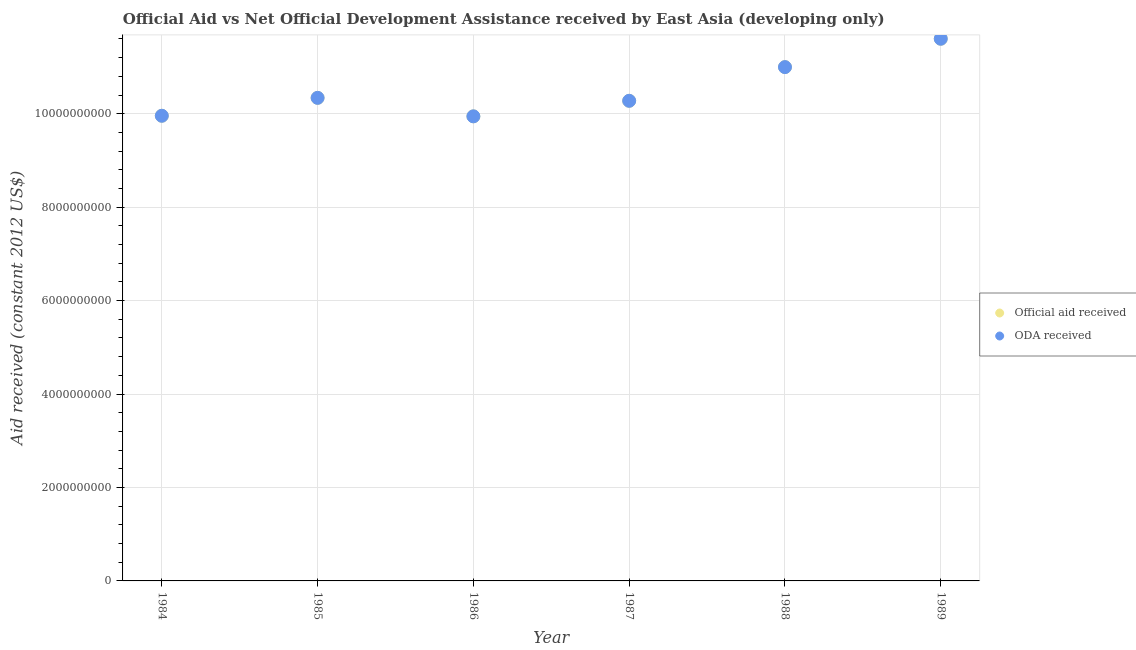How many different coloured dotlines are there?
Keep it short and to the point. 2. What is the oda received in 1988?
Your answer should be very brief. 1.10e+1. Across all years, what is the maximum oda received?
Provide a short and direct response. 1.16e+1. Across all years, what is the minimum oda received?
Your answer should be very brief. 9.94e+09. In which year was the oda received maximum?
Your answer should be compact. 1989. What is the total oda received in the graph?
Provide a succinct answer. 6.31e+1. What is the difference between the official aid received in 1984 and that in 1987?
Give a very brief answer. -3.20e+08. What is the difference between the oda received in 1985 and the official aid received in 1987?
Ensure brevity in your answer.  6.34e+07. What is the average oda received per year?
Provide a short and direct response. 1.05e+1. In how many years, is the oda received greater than 4400000000 US$?
Give a very brief answer. 6. What is the ratio of the official aid received in 1988 to that in 1989?
Make the answer very short. 0.95. Is the difference between the oda received in 1985 and 1988 greater than the difference between the official aid received in 1985 and 1988?
Your answer should be very brief. No. What is the difference between the highest and the second highest oda received?
Give a very brief answer. 6.07e+08. What is the difference between the highest and the lowest oda received?
Keep it short and to the point. 1.66e+09. In how many years, is the official aid received greater than the average official aid received taken over all years?
Your response must be concise. 2. Is the sum of the oda received in 1986 and 1987 greater than the maximum official aid received across all years?
Offer a very short reply. Yes. Is the official aid received strictly greater than the oda received over the years?
Your answer should be compact. No. Is the oda received strictly less than the official aid received over the years?
Make the answer very short. No. Does the graph contain any zero values?
Provide a succinct answer. No. Does the graph contain grids?
Ensure brevity in your answer.  Yes. What is the title of the graph?
Provide a short and direct response. Official Aid vs Net Official Development Assistance received by East Asia (developing only) . What is the label or title of the Y-axis?
Ensure brevity in your answer.  Aid received (constant 2012 US$). What is the Aid received (constant 2012 US$) in Official aid received in 1984?
Keep it short and to the point. 9.96e+09. What is the Aid received (constant 2012 US$) of ODA received in 1984?
Keep it short and to the point. 9.96e+09. What is the Aid received (constant 2012 US$) in Official aid received in 1985?
Make the answer very short. 1.03e+1. What is the Aid received (constant 2012 US$) of ODA received in 1985?
Offer a terse response. 1.03e+1. What is the Aid received (constant 2012 US$) of Official aid received in 1986?
Your response must be concise. 9.94e+09. What is the Aid received (constant 2012 US$) of ODA received in 1986?
Your response must be concise. 9.94e+09. What is the Aid received (constant 2012 US$) of Official aid received in 1987?
Provide a succinct answer. 1.03e+1. What is the Aid received (constant 2012 US$) in ODA received in 1987?
Give a very brief answer. 1.03e+1. What is the Aid received (constant 2012 US$) in Official aid received in 1988?
Give a very brief answer. 1.10e+1. What is the Aid received (constant 2012 US$) of ODA received in 1988?
Your answer should be compact. 1.10e+1. What is the Aid received (constant 2012 US$) of Official aid received in 1989?
Give a very brief answer. 1.16e+1. What is the Aid received (constant 2012 US$) in ODA received in 1989?
Your answer should be very brief. 1.16e+1. Across all years, what is the maximum Aid received (constant 2012 US$) of Official aid received?
Keep it short and to the point. 1.16e+1. Across all years, what is the maximum Aid received (constant 2012 US$) in ODA received?
Your answer should be compact. 1.16e+1. Across all years, what is the minimum Aid received (constant 2012 US$) of Official aid received?
Keep it short and to the point. 9.94e+09. Across all years, what is the minimum Aid received (constant 2012 US$) of ODA received?
Give a very brief answer. 9.94e+09. What is the total Aid received (constant 2012 US$) of Official aid received in the graph?
Provide a short and direct response. 6.31e+1. What is the total Aid received (constant 2012 US$) of ODA received in the graph?
Provide a short and direct response. 6.31e+1. What is the difference between the Aid received (constant 2012 US$) of Official aid received in 1984 and that in 1985?
Ensure brevity in your answer.  -3.84e+08. What is the difference between the Aid received (constant 2012 US$) of ODA received in 1984 and that in 1985?
Provide a short and direct response. -3.84e+08. What is the difference between the Aid received (constant 2012 US$) of Official aid received in 1984 and that in 1986?
Provide a succinct answer. 1.23e+07. What is the difference between the Aid received (constant 2012 US$) in ODA received in 1984 and that in 1986?
Your response must be concise. 1.23e+07. What is the difference between the Aid received (constant 2012 US$) in Official aid received in 1984 and that in 1987?
Your response must be concise. -3.20e+08. What is the difference between the Aid received (constant 2012 US$) of ODA received in 1984 and that in 1987?
Your answer should be compact. -3.20e+08. What is the difference between the Aid received (constant 2012 US$) in Official aid received in 1984 and that in 1988?
Make the answer very short. -1.04e+09. What is the difference between the Aid received (constant 2012 US$) of ODA received in 1984 and that in 1988?
Keep it short and to the point. -1.04e+09. What is the difference between the Aid received (constant 2012 US$) in Official aid received in 1984 and that in 1989?
Offer a very short reply. -1.65e+09. What is the difference between the Aid received (constant 2012 US$) of ODA received in 1984 and that in 1989?
Ensure brevity in your answer.  -1.65e+09. What is the difference between the Aid received (constant 2012 US$) of Official aid received in 1985 and that in 1986?
Make the answer very short. 3.96e+08. What is the difference between the Aid received (constant 2012 US$) in ODA received in 1985 and that in 1986?
Keep it short and to the point. 3.96e+08. What is the difference between the Aid received (constant 2012 US$) of Official aid received in 1985 and that in 1987?
Keep it short and to the point. 6.34e+07. What is the difference between the Aid received (constant 2012 US$) of ODA received in 1985 and that in 1987?
Your response must be concise. 6.34e+07. What is the difference between the Aid received (constant 2012 US$) in Official aid received in 1985 and that in 1988?
Make the answer very short. -6.58e+08. What is the difference between the Aid received (constant 2012 US$) in ODA received in 1985 and that in 1988?
Ensure brevity in your answer.  -6.58e+08. What is the difference between the Aid received (constant 2012 US$) of Official aid received in 1985 and that in 1989?
Provide a short and direct response. -1.26e+09. What is the difference between the Aid received (constant 2012 US$) in ODA received in 1985 and that in 1989?
Your response must be concise. -1.26e+09. What is the difference between the Aid received (constant 2012 US$) of Official aid received in 1986 and that in 1987?
Provide a succinct answer. -3.32e+08. What is the difference between the Aid received (constant 2012 US$) of ODA received in 1986 and that in 1987?
Make the answer very short. -3.32e+08. What is the difference between the Aid received (constant 2012 US$) of Official aid received in 1986 and that in 1988?
Make the answer very short. -1.05e+09. What is the difference between the Aid received (constant 2012 US$) in ODA received in 1986 and that in 1988?
Provide a succinct answer. -1.05e+09. What is the difference between the Aid received (constant 2012 US$) of Official aid received in 1986 and that in 1989?
Offer a terse response. -1.66e+09. What is the difference between the Aid received (constant 2012 US$) of ODA received in 1986 and that in 1989?
Provide a short and direct response. -1.66e+09. What is the difference between the Aid received (constant 2012 US$) in Official aid received in 1987 and that in 1988?
Ensure brevity in your answer.  -7.21e+08. What is the difference between the Aid received (constant 2012 US$) in ODA received in 1987 and that in 1988?
Make the answer very short. -7.21e+08. What is the difference between the Aid received (constant 2012 US$) of Official aid received in 1987 and that in 1989?
Give a very brief answer. -1.33e+09. What is the difference between the Aid received (constant 2012 US$) in ODA received in 1987 and that in 1989?
Make the answer very short. -1.33e+09. What is the difference between the Aid received (constant 2012 US$) in Official aid received in 1988 and that in 1989?
Offer a terse response. -6.07e+08. What is the difference between the Aid received (constant 2012 US$) in ODA received in 1988 and that in 1989?
Keep it short and to the point. -6.07e+08. What is the difference between the Aid received (constant 2012 US$) in Official aid received in 1984 and the Aid received (constant 2012 US$) in ODA received in 1985?
Provide a succinct answer. -3.84e+08. What is the difference between the Aid received (constant 2012 US$) in Official aid received in 1984 and the Aid received (constant 2012 US$) in ODA received in 1986?
Your response must be concise. 1.23e+07. What is the difference between the Aid received (constant 2012 US$) in Official aid received in 1984 and the Aid received (constant 2012 US$) in ODA received in 1987?
Your answer should be compact. -3.20e+08. What is the difference between the Aid received (constant 2012 US$) in Official aid received in 1984 and the Aid received (constant 2012 US$) in ODA received in 1988?
Ensure brevity in your answer.  -1.04e+09. What is the difference between the Aid received (constant 2012 US$) of Official aid received in 1984 and the Aid received (constant 2012 US$) of ODA received in 1989?
Your answer should be compact. -1.65e+09. What is the difference between the Aid received (constant 2012 US$) of Official aid received in 1985 and the Aid received (constant 2012 US$) of ODA received in 1986?
Provide a short and direct response. 3.96e+08. What is the difference between the Aid received (constant 2012 US$) of Official aid received in 1985 and the Aid received (constant 2012 US$) of ODA received in 1987?
Your response must be concise. 6.34e+07. What is the difference between the Aid received (constant 2012 US$) in Official aid received in 1985 and the Aid received (constant 2012 US$) in ODA received in 1988?
Your response must be concise. -6.58e+08. What is the difference between the Aid received (constant 2012 US$) of Official aid received in 1985 and the Aid received (constant 2012 US$) of ODA received in 1989?
Offer a terse response. -1.26e+09. What is the difference between the Aid received (constant 2012 US$) of Official aid received in 1986 and the Aid received (constant 2012 US$) of ODA received in 1987?
Give a very brief answer. -3.32e+08. What is the difference between the Aid received (constant 2012 US$) in Official aid received in 1986 and the Aid received (constant 2012 US$) in ODA received in 1988?
Offer a terse response. -1.05e+09. What is the difference between the Aid received (constant 2012 US$) in Official aid received in 1986 and the Aid received (constant 2012 US$) in ODA received in 1989?
Ensure brevity in your answer.  -1.66e+09. What is the difference between the Aid received (constant 2012 US$) of Official aid received in 1987 and the Aid received (constant 2012 US$) of ODA received in 1988?
Ensure brevity in your answer.  -7.21e+08. What is the difference between the Aid received (constant 2012 US$) of Official aid received in 1987 and the Aid received (constant 2012 US$) of ODA received in 1989?
Make the answer very short. -1.33e+09. What is the difference between the Aid received (constant 2012 US$) of Official aid received in 1988 and the Aid received (constant 2012 US$) of ODA received in 1989?
Your answer should be very brief. -6.07e+08. What is the average Aid received (constant 2012 US$) in Official aid received per year?
Ensure brevity in your answer.  1.05e+1. What is the average Aid received (constant 2012 US$) of ODA received per year?
Provide a succinct answer. 1.05e+1. What is the ratio of the Aid received (constant 2012 US$) in Official aid received in 1984 to that in 1985?
Your answer should be very brief. 0.96. What is the ratio of the Aid received (constant 2012 US$) in ODA received in 1984 to that in 1985?
Your answer should be very brief. 0.96. What is the ratio of the Aid received (constant 2012 US$) of Official aid received in 1984 to that in 1986?
Give a very brief answer. 1. What is the ratio of the Aid received (constant 2012 US$) of ODA received in 1984 to that in 1986?
Give a very brief answer. 1. What is the ratio of the Aid received (constant 2012 US$) of Official aid received in 1984 to that in 1987?
Provide a short and direct response. 0.97. What is the ratio of the Aid received (constant 2012 US$) in ODA received in 1984 to that in 1987?
Give a very brief answer. 0.97. What is the ratio of the Aid received (constant 2012 US$) in Official aid received in 1984 to that in 1988?
Give a very brief answer. 0.91. What is the ratio of the Aid received (constant 2012 US$) in ODA received in 1984 to that in 1988?
Make the answer very short. 0.91. What is the ratio of the Aid received (constant 2012 US$) of Official aid received in 1984 to that in 1989?
Make the answer very short. 0.86. What is the ratio of the Aid received (constant 2012 US$) in ODA received in 1984 to that in 1989?
Ensure brevity in your answer.  0.86. What is the ratio of the Aid received (constant 2012 US$) in Official aid received in 1985 to that in 1986?
Offer a terse response. 1.04. What is the ratio of the Aid received (constant 2012 US$) in ODA received in 1985 to that in 1986?
Your answer should be very brief. 1.04. What is the ratio of the Aid received (constant 2012 US$) of ODA received in 1985 to that in 1987?
Provide a short and direct response. 1.01. What is the ratio of the Aid received (constant 2012 US$) in Official aid received in 1985 to that in 1988?
Give a very brief answer. 0.94. What is the ratio of the Aid received (constant 2012 US$) of ODA received in 1985 to that in 1988?
Keep it short and to the point. 0.94. What is the ratio of the Aid received (constant 2012 US$) of Official aid received in 1985 to that in 1989?
Your response must be concise. 0.89. What is the ratio of the Aid received (constant 2012 US$) in ODA received in 1985 to that in 1989?
Keep it short and to the point. 0.89. What is the ratio of the Aid received (constant 2012 US$) of Official aid received in 1986 to that in 1987?
Ensure brevity in your answer.  0.97. What is the ratio of the Aid received (constant 2012 US$) of ODA received in 1986 to that in 1987?
Provide a succinct answer. 0.97. What is the ratio of the Aid received (constant 2012 US$) of Official aid received in 1986 to that in 1988?
Offer a terse response. 0.9. What is the ratio of the Aid received (constant 2012 US$) in ODA received in 1986 to that in 1988?
Make the answer very short. 0.9. What is the ratio of the Aid received (constant 2012 US$) of Official aid received in 1986 to that in 1989?
Your answer should be compact. 0.86. What is the ratio of the Aid received (constant 2012 US$) of ODA received in 1986 to that in 1989?
Keep it short and to the point. 0.86. What is the ratio of the Aid received (constant 2012 US$) in Official aid received in 1987 to that in 1988?
Keep it short and to the point. 0.93. What is the ratio of the Aid received (constant 2012 US$) of ODA received in 1987 to that in 1988?
Your response must be concise. 0.93. What is the ratio of the Aid received (constant 2012 US$) in Official aid received in 1987 to that in 1989?
Your response must be concise. 0.89. What is the ratio of the Aid received (constant 2012 US$) in ODA received in 1987 to that in 1989?
Your answer should be very brief. 0.89. What is the ratio of the Aid received (constant 2012 US$) in Official aid received in 1988 to that in 1989?
Provide a short and direct response. 0.95. What is the ratio of the Aid received (constant 2012 US$) of ODA received in 1988 to that in 1989?
Your response must be concise. 0.95. What is the difference between the highest and the second highest Aid received (constant 2012 US$) of Official aid received?
Provide a short and direct response. 6.07e+08. What is the difference between the highest and the second highest Aid received (constant 2012 US$) of ODA received?
Your answer should be compact. 6.07e+08. What is the difference between the highest and the lowest Aid received (constant 2012 US$) in Official aid received?
Provide a succinct answer. 1.66e+09. What is the difference between the highest and the lowest Aid received (constant 2012 US$) of ODA received?
Ensure brevity in your answer.  1.66e+09. 